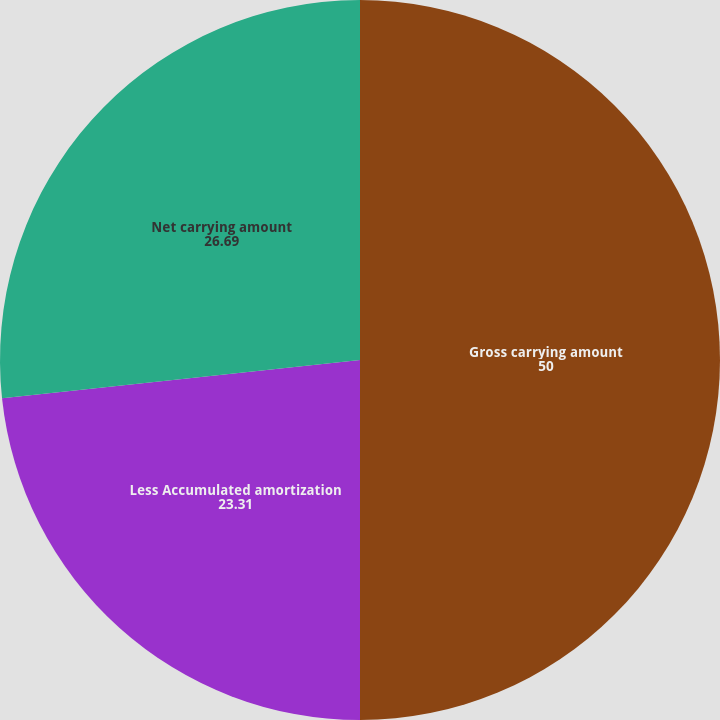Convert chart. <chart><loc_0><loc_0><loc_500><loc_500><pie_chart><fcel>Gross carrying amount<fcel>Less Accumulated amortization<fcel>Net carrying amount<nl><fcel>50.0%<fcel>23.31%<fcel>26.69%<nl></chart> 